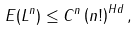<formula> <loc_0><loc_0><loc_500><loc_500>E ( L ^ { n } ) \leq C ^ { n } \left ( n ! \right ) ^ { H d } ,</formula> 